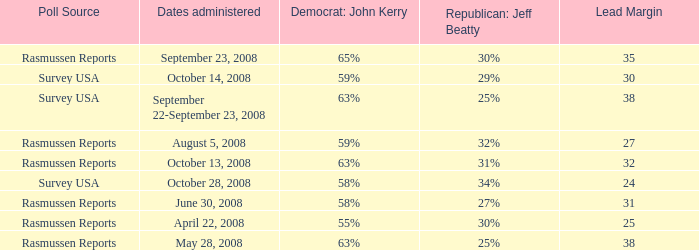What is hte date where republican jeaff beatty is 34%? October 28, 2008. 